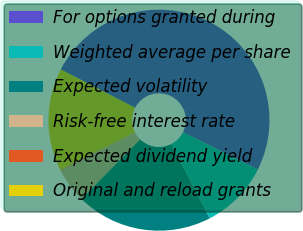Convert chart to OTSL. <chart><loc_0><loc_0><loc_500><loc_500><pie_chart><fcel>For options granted during<fcel>Weighted average per share<fcel>Expected volatility<fcel>Risk-free interest rate<fcel>Expected dividend yield<fcel>Original and reload grants<nl><fcel>49.8%<fcel>10.04%<fcel>19.98%<fcel>5.07%<fcel>0.1%<fcel>15.01%<nl></chart> 